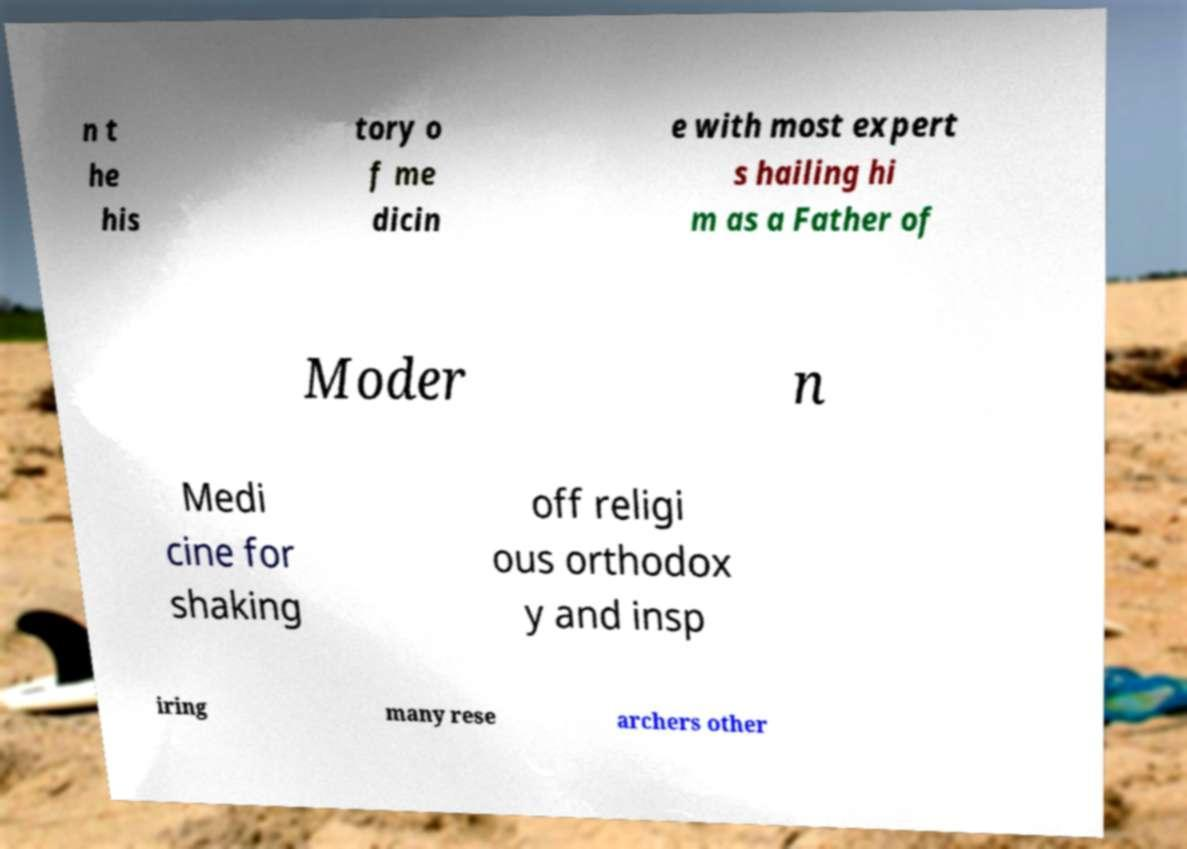Could you assist in decoding the text presented in this image and type it out clearly? n t he his tory o f me dicin e with most expert s hailing hi m as a Father of Moder n Medi cine for shaking off religi ous orthodox y and insp iring many rese archers other 